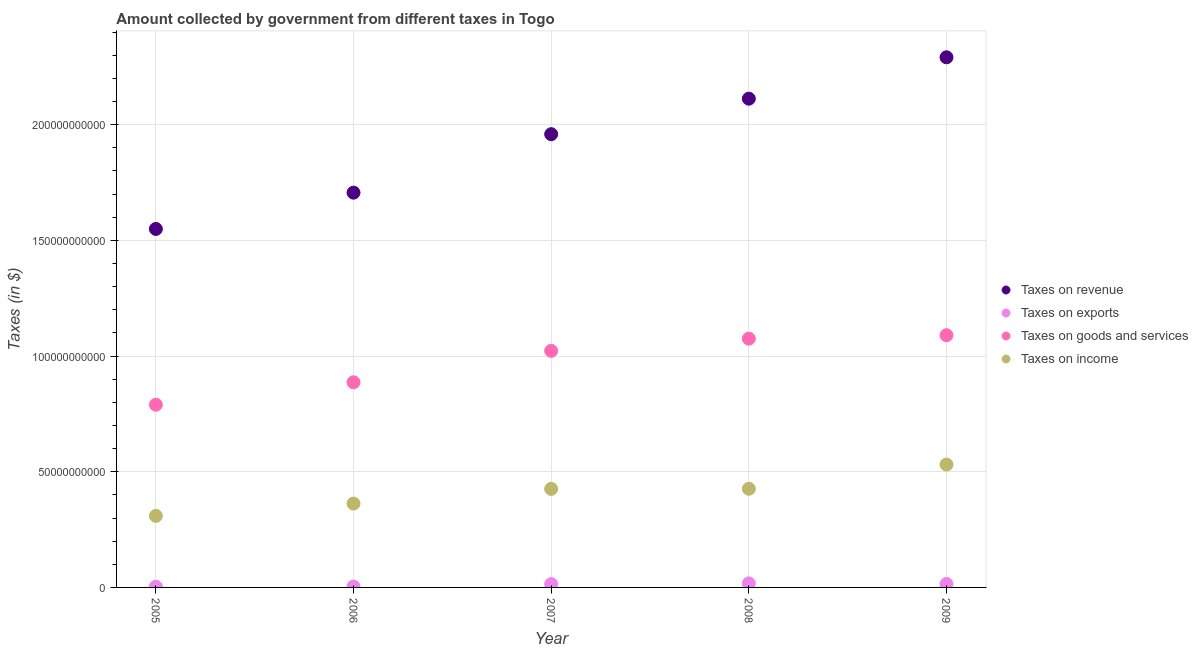Is the number of dotlines equal to the number of legend labels?
Offer a very short reply. Yes. What is the amount collected as tax on revenue in 2006?
Your answer should be compact. 1.71e+11. Across all years, what is the maximum amount collected as tax on goods?
Your response must be concise. 1.09e+11. Across all years, what is the minimum amount collected as tax on revenue?
Keep it short and to the point. 1.55e+11. In which year was the amount collected as tax on exports maximum?
Make the answer very short. 2008. What is the total amount collected as tax on revenue in the graph?
Make the answer very short. 9.62e+11. What is the difference between the amount collected as tax on income in 2006 and that in 2009?
Give a very brief answer. -1.69e+1. What is the difference between the amount collected as tax on income in 2006 and the amount collected as tax on goods in 2008?
Your answer should be very brief. -7.13e+1. What is the average amount collected as tax on revenue per year?
Your response must be concise. 1.92e+11. In the year 2009, what is the difference between the amount collected as tax on goods and amount collected as tax on revenue?
Provide a succinct answer. -1.20e+11. In how many years, is the amount collected as tax on income greater than 220000000000 $?
Make the answer very short. 0. What is the ratio of the amount collected as tax on goods in 2006 to that in 2009?
Make the answer very short. 0.81. Is the amount collected as tax on income in 2005 less than that in 2007?
Your response must be concise. Yes. Is the difference between the amount collected as tax on income in 2005 and 2009 greater than the difference between the amount collected as tax on revenue in 2005 and 2009?
Provide a short and direct response. Yes. What is the difference between the highest and the second highest amount collected as tax on income?
Make the answer very short. 1.05e+1. What is the difference between the highest and the lowest amount collected as tax on exports?
Make the answer very short. 1.45e+09. In how many years, is the amount collected as tax on goods greater than the average amount collected as tax on goods taken over all years?
Your answer should be very brief. 3. Is the sum of the amount collected as tax on revenue in 2007 and 2008 greater than the maximum amount collected as tax on exports across all years?
Ensure brevity in your answer.  Yes. Is it the case that in every year, the sum of the amount collected as tax on revenue and amount collected as tax on exports is greater than the amount collected as tax on goods?
Your answer should be compact. Yes. Is the amount collected as tax on income strictly greater than the amount collected as tax on revenue over the years?
Ensure brevity in your answer.  No. Is the amount collected as tax on revenue strictly less than the amount collected as tax on exports over the years?
Your answer should be compact. No. How many dotlines are there?
Provide a short and direct response. 4. How many years are there in the graph?
Your answer should be compact. 5. What is the difference between two consecutive major ticks on the Y-axis?
Your answer should be compact. 5.00e+1. Are the values on the major ticks of Y-axis written in scientific E-notation?
Make the answer very short. No. Does the graph contain any zero values?
Provide a succinct answer. No. How are the legend labels stacked?
Give a very brief answer. Vertical. What is the title of the graph?
Your answer should be very brief. Amount collected by government from different taxes in Togo. Does "Australia" appear as one of the legend labels in the graph?
Keep it short and to the point. No. What is the label or title of the Y-axis?
Your answer should be compact. Taxes (in $). What is the Taxes (in $) in Taxes on revenue in 2005?
Offer a very short reply. 1.55e+11. What is the Taxes (in $) of Taxes on exports in 2005?
Make the answer very short. 3.14e+08. What is the Taxes (in $) in Taxes on goods and services in 2005?
Ensure brevity in your answer.  7.90e+1. What is the Taxes (in $) in Taxes on income in 2005?
Ensure brevity in your answer.  3.09e+1. What is the Taxes (in $) in Taxes on revenue in 2006?
Provide a succinct answer. 1.71e+11. What is the Taxes (in $) in Taxes on exports in 2006?
Keep it short and to the point. 3.91e+08. What is the Taxes (in $) in Taxes on goods and services in 2006?
Your response must be concise. 8.86e+1. What is the Taxes (in $) in Taxes on income in 2006?
Your answer should be very brief. 3.62e+1. What is the Taxes (in $) of Taxes on revenue in 2007?
Offer a terse response. 1.96e+11. What is the Taxes (in $) in Taxes on exports in 2007?
Provide a succinct answer. 1.43e+09. What is the Taxes (in $) of Taxes on goods and services in 2007?
Offer a terse response. 1.02e+11. What is the Taxes (in $) in Taxes on income in 2007?
Your answer should be very brief. 4.26e+1. What is the Taxes (in $) in Taxes on revenue in 2008?
Make the answer very short. 2.11e+11. What is the Taxes (in $) in Taxes on exports in 2008?
Ensure brevity in your answer.  1.76e+09. What is the Taxes (in $) of Taxes on goods and services in 2008?
Provide a short and direct response. 1.08e+11. What is the Taxes (in $) of Taxes on income in 2008?
Offer a terse response. 4.26e+1. What is the Taxes (in $) of Taxes on revenue in 2009?
Make the answer very short. 2.29e+11. What is the Taxes (in $) of Taxes on exports in 2009?
Offer a very short reply. 1.51e+09. What is the Taxes (in $) in Taxes on goods and services in 2009?
Provide a succinct answer. 1.09e+11. What is the Taxes (in $) of Taxes on income in 2009?
Offer a very short reply. 5.31e+1. Across all years, what is the maximum Taxes (in $) in Taxes on revenue?
Provide a short and direct response. 2.29e+11. Across all years, what is the maximum Taxes (in $) in Taxes on exports?
Provide a short and direct response. 1.76e+09. Across all years, what is the maximum Taxes (in $) in Taxes on goods and services?
Provide a short and direct response. 1.09e+11. Across all years, what is the maximum Taxes (in $) of Taxes on income?
Provide a short and direct response. 5.31e+1. Across all years, what is the minimum Taxes (in $) in Taxes on revenue?
Keep it short and to the point. 1.55e+11. Across all years, what is the minimum Taxes (in $) of Taxes on exports?
Provide a short and direct response. 3.14e+08. Across all years, what is the minimum Taxes (in $) in Taxes on goods and services?
Ensure brevity in your answer.  7.90e+1. Across all years, what is the minimum Taxes (in $) in Taxes on income?
Give a very brief answer. 3.09e+1. What is the total Taxes (in $) in Taxes on revenue in the graph?
Keep it short and to the point. 9.62e+11. What is the total Taxes (in $) in Taxes on exports in the graph?
Offer a terse response. 5.40e+09. What is the total Taxes (in $) in Taxes on goods and services in the graph?
Your answer should be very brief. 4.86e+11. What is the total Taxes (in $) of Taxes on income in the graph?
Your answer should be very brief. 2.05e+11. What is the difference between the Taxes (in $) in Taxes on revenue in 2005 and that in 2006?
Make the answer very short. -1.57e+1. What is the difference between the Taxes (in $) in Taxes on exports in 2005 and that in 2006?
Offer a very short reply. -7.76e+07. What is the difference between the Taxes (in $) of Taxes on goods and services in 2005 and that in 2006?
Your response must be concise. -9.68e+09. What is the difference between the Taxes (in $) in Taxes on income in 2005 and that in 2006?
Your answer should be very brief. -5.30e+09. What is the difference between the Taxes (in $) of Taxes on revenue in 2005 and that in 2007?
Provide a short and direct response. -4.10e+1. What is the difference between the Taxes (in $) of Taxes on exports in 2005 and that in 2007?
Your answer should be very brief. -1.12e+09. What is the difference between the Taxes (in $) in Taxes on goods and services in 2005 and that in 2007?
Provide a succinct answer. -2.33e+1. What is the difference between the Taxes (in $) of Taxes on income in 2005 and that in 2007?
Keep it short and to the point. -1.17e+1. What is the difference between the Taxes (in $) in Taxes on revenue in 2005 and that in 2008?
Your answer should be compact. -5.63e+1. What is the difference between the Taxes (in $) in Taxes on exports in 2005 and that in 2008?
Give a very brief answer. -1.45e+09. What is the difference between the Taxes (in $) of Taxes on goods and services in 2005 and that in 2008?
Keep it short and to the point. -2.85e+1. What is the difference between the Taxes (in $) in Taxes on income in 2005 and that in 2008?
Provide a short and direct response. -1.17e+1. What is the difference between the Taxes (in $) of Taxes on revenue in 2005 and that in 2009?
Offer a very short reply. -7.42e+1. What is the difference between the Taxes (in $) in Taxes on exports in 2005 and that in 2009?
Offer a very short reply. -1.19e+09. What is the difference between the Taxes (in $) in Taxes on goods and services in 2005 and that in 2009?
Give a very brief answer. -3.00e+1. What is the difference between the Taxes (in $) of Taxes on income in 2005 and that in 2009?
Offer a terse response. -2.22e+1. What is the difference between the Taxes (in $) in Taxes on revenue in 2006 and that in 2007?
Your answer should be compact. -2.53e+1. What is the difference between the Taxes (in $) of Taxes on exports in 2006 and that in 2007?
Offer a terse response. -1.04e+09. What is the difference between the Taxes (in $) of Taxes on goods and services in 2006 and that in 2007?
Your answer should be very brief. -1.36e+1. What is the difference between the Taxes (in $) of Taxes on income in 2006 and that in 2007?
Give a very brief answer. -6.35e+09. What is the difference between the Taxes (in $) of Taxes on revenue in 2006 and that in 2008?
Give a very brief answer. -4.06e+1. What is the difference between the Taxes (in $) of Taxes on exports in 2006 and that in 2008?
Your answer should be compact. -1.37e+09. What is the difference between the Taxes (in $) in Taxes on goods and services in 2006 and that in 2008?
Provide a short and direct response. -1.89e+1. What is the difference between the Taxes (in $) of Taxes on income in 2006 and that in 2008?
Give a very brief answer. -6.41e+09. What is the difference between the Taxes (in $) in Taxes on revenue in 2006 and that in 2009?
Your answer should be compact. -5.85e+1. What is the difference between the Taxes (in $) in Taxes on exports in 2006 and that in 2009?
Give a very brief answer. -1.11e+09. What is the difference between the Taxes (in $) of Taxes on goods and services in 2006 and that in 2009?
Offer a very short reply. -2.04e+1. What is the difference between the Taxes (in $) of Taxes on income in 2006 and that in 2009?
Your answer should be very brief. -1.69e+1. What is the difference between the Taxes (in $) of Taxes on revenue in 2007 and that in 2008?
Give a very brief answer. -1.53e+1. What is the difference between the Taxes (in $) in Taxes on exports in 2007 and that in 2008?
Offer a terse response. -3.30e+08. What is the difference between the Taxes (in $) in Taxes on goods and services in 2007 and that in 2008?
Give a very brief answer. -5.28e+09. What is the difference between the Taxes (in $) in Taxes on income in 2007 and that in 2008?
Your response must be concise. -5.46e+07. What is the difference between the Taxes (in $) in Taxes on revenue in 2007 and that in 2009?
Your answer should be compact. -3.32e+1. What is the difference between the Taxes (in $) in Taxes on exports in 2007 and that in 2009?
Your answer should be very brief. -7.58e+07. What is the difference between the Taxes (in $) of Taxes on goods and services in 2007 and that in 2009?
Your answer should be very brief. -6.76e+09. What is the difference between the Taxes (in $) of Taxes on income in 2007 and that in 2009?
Ensure brevity in your answer.  -1.05e+1. What is the difference between the Taxes (in $) in Taxes on revenue in 2008 and that in 2009?
Make the answer very short. -1.79e+1. What is the difference between the Taxes (in $) in Taxes on exports in 2008 and that in 2009?
Keep it short and to the point. 2.54e+08. What is the difference between the Taxes (in $) in Taxes on goods and services in 2008 and that in 2009?
Give a very brief answer. -1.49e+09. What is the difference between the Taxes (in $) of Taxes on income in 2008 and that in 2009?
Keep it short and to the point. -1.05e+1. What is the difference between the Taxes (in $) of Taxes on revenue in 2005 and the Taxes (in $) of Taxes on exports in 2006?
Give a very brief answer. 1.55e+11. What is the difference between the Taxes (in $) of Taxes on revenue in 2005 and the Taxes (in $) of Taxes on goods and services in 2006?
Provide a short and direct response. 6.63e+1. What is the difference between the Taxes (in $) of Taxes on revenue in 2005 and the Taxes (in $) of Taxes on income in 2006?
Your answer should be very brief. 1.19e+11. What is the difference between the Taxes (in $) of Taxes on exports in 2005 and the Taxes (in $) of Taxes on goods and services in 2006?
Keep it short and to the point. -8.83e+1. What is the difference between the Taxes (in $) of Taxes on exports in 2005 and the Taxes (in $) of Taxes on income in 2006?
Ensure brevity in your answer.  -3.59e+1. What is the difference between the Taxes (in $) of Taxes on goods and services in 2005 and the Taxes (in $) of Taxes on income in 2006?
Your response must be concise. 4.27e+1. What is the difference between the Taxes (in $) in Taxes on revenue in 2005 and the Taxes (in $) in Taxes on exports in 2007?
Provide a short and direct response. 1.53e+11. What is the difference between the Taxes (in $) of Taxes on revenue in 2005 and the Taxes (in $) of Taxes on goods and services in 2007?
Provide a short and direct response. 5.27e+1. What is the difference between the Taxes (in $) in Taxes on revenue in 2005 and the Taxes (in $) in Taxes on income in 2007?
Make the answer very short. 1.12e+11. What is the difference between the Taxes (in $) in Taxes on exports in 2005 and the Taxes (in $) in Taxes on goods and services in 2007?
Provide a succinct answer. -1.02e+11. What is the difference between the Taxes (in $) in Taxes on exports in 2005 and the Taxes (in $) in Taxes on income in 2007?
Give a very brief answer. -4.23e+1. What is the difference between the Taxes (in $) of Taxes on goods and services in 2005 and the Taxes (in $) of Taxes on income in 2007?
Ensure brevity in your answer.  3.64e+1. What is the difference between the Taxes (in $) in Taxes on revenue in 2005 and the Taxes (in $) in Taxes on exports in 2008?
Ensure brevity in your answer.  1.53e+11. What is the difference between the Taxes (in $) in Taxes on revenue in 2005 and the Taxes (in $) in Taxes on goods and services in 2008?
Your response must be concise. 4.74e+1. What is the difference between the Taxes (in $) of Taxes on revenue in 2005 and the Taxes (in $) of Taxes on income in 2008?
Your answer should be compact. 1.12e+11. What is the difference between the Taxes (in $) of Taxes on exports in 2005 and the Taxes (in $) of Taxes on goods and services in 2008?
Your response must be concise. -1.07e+11. What is the difference between the Taxes (in $) in Taxes on exports in 2005 and the Taxes (in $) in Taxes on income in 2008?
Give a very brief answer. -4.23e+1. What is the difference between the Taxes (in $) in Taxes on goods and services in 2005 and the Taxes (in $) in Taxes on income in 2008?
Give a very brief answer. 3.63e+1. What is the difference between the Taxes (in $) of Taxes on revenue in 2005 and the Taxes (in $) of Taxes on exports in 2009?
Keep it short and to the point. 1.53e+11. What is the difference between the Taxes (in $) in Taxes on revenue in 2005 and the Taxes (in $) in Taxes on goods and services in 2009?
Keep it short and to the point. 4.59e+1. What is the difference between the Taxes (in $) in Taxes on revenue in 2005 and the Taxes (in $) in Taxes on income in 2009?
Give a very brief answer. 1.02e+11. What is the difference between the Taxes (in $) of Taxes on exports in 2005 and the Taxes (in $) of Taxes on goods and services in 2009?
Offer a very short reply. -1.09e+11. What is the difference between the Taxes (in $) in Taxes on exports in 2005 and the Taxes (in $) in Taxes on income in 2009?
Keep it short and to the point. -5.28e+1. What is the difference between the Taxes (in $) in Taxes on goods and services in 2005 and the Taxes (in $) in Taxes on income in 2009?
Your response must be concise. 2.59e+1. What is the difference between the Taxes (in $) of Taxes on revenue in 2006 and the Taxes (in $) of Taxes on exports in 2007?
Ensure brevity in your answer.  1.69e+11. What is the difference between the Taxes (in $) of Taxes on revenue in 2006 and the Taxes (in $) of Taxes on goods and services in 2007?
Your response must be concise. 6.84e+1. What is the difference between the Taxes (in $) of Taxes on revenue in 2006 and the Taxes (in $) of Taxes on income in 2007?
Ensure brevity in your answer.  1.28e+11. What is the difference between the Taxes (in $) in Taxes on exports in 2006 and the Taxes (in $) in Taxes on goods and services in 2007?
Give a very brief answer. -1.02e+11. What is the difference between the Taxes (in $) in Taxes on exports in 2006 and the Taxes (in $) in Taxes on income in 2007?
Your response must be concise. -4.22e+1. What is the difference between the Taxes (in $) in Taxes on goods and services in 2006 and the Taxes (in $) in Taxes on income in 2007?
Provide a short and direct response. 4.61e+1. What is the difference between the Taxes (in $) in Taxes on revenue in 2006 and the Taxes (in $) in Taxes on exports in 2008?
Provide a succinct answer. 1.69e+11. What is the difference between the Taxes (in $) in Taxes on revenue in 2006 and the Taxes (in $) in Taxes on goods and services in 2008?
Your answer should be compact. 6.31e+1. What is the difference between the Taxes (in $) of Taxes on revenue in 2006 and the Taxes (in $) of Taxes on income in 2008?
Offer a terse response. 1.28e+11. What is the difference between the Taxes (in $) of Taxes on exports in 2006 and the Taxes (in $) of Taxes on goods and services in 2008?
Give a very brief answer. -1.07e+11. What is the difference between the Taxes (in $) of Taxes on exports in 2006 and the Taxes (in $) of Taxes on income in 2008?
Keep it short and to the point. -4.22e+1. What is the difference between the Taxes (in $) of Taxes on goods and services in 2006 and the Taxes (in $) of Taxes on income in 2008?
Your answer should be very brief. 4.60e+1. What is the difference between the Taxes (in $) of Taxes on revenue in 2006 and the Taxes (in $) of Taxes on exports in 2009?
Provide a short and direct response. 1.69e+11. What is the difference between the Taxes (in $) of Taxes on revenue in 2006 and the Taxes (in $) of Taxes on goods and services in 2009?
Offer a very short reply. 6.16e+1. What is the difference between the Taxes (in $) in Taxes on revenue in 2006 and the Taxes (in $) in Taxes on income in 2009?
Make the answer very short. 1.17e+11. What is the difference between the Taxes (in $) of Taxes on exports in 2006 and the Taxes (in $) of Taxes on goods and services in 2009?
Offer a very short reply. -1.09e+11. What is the difference between the Taxes (in $) in Taxes on exports in 2006 and the Taxes (in $) in Taxes on income in 2009?
Offer a terse response. -5.27e+1. What is the difference between the Taxes (in $) in Taxes on goods and services in 2006 and the Taxes (in $) in Taxes on income in 2009?
Make the answer very short. 3.55e+1. What is the difference between the Taxes (in $) in Taxes on revenue in 2007 and the Taxes (in $) in Taxes on exports in 2008?
Your response must be concise. 1.94e+11. What is the difference between the Taxes (in $) of Taxes on revenue in 2007 and the Taxes (in $) of Taxes on goods and services in 2008?
Your answer should be very brief. 8.84e+1. What is the difference between the Taxes (in $) of Taxes on revenue in 2007 and the Taxes (in $) of Taxes on income in 2008?
Give a very brief answer. 1.53e+11. What is the difference between the Taxes (in $) in Taxes on exports in 2007 and the Taxes (in $) in Taxes on goods and services in 2008?
Keep it short and to the point. -1.06e+11. What is the difference between the Taxes (in $) of Taxes on exports in 2007 and the Taxes (in $) of Taxes on income in 2008?
Provide a short and direct response. -4.12e+1. What is the difference between the Taxes (in $) in Taxes on goods and services in 2007 and the Taxes (in $) in Taxes on income in 2008?
Make the answer very short. 5.96e+1. What is the difference between the Taxes (in $) of Taxes on revenue in 2007 and the Taxes (in $) of Taxes on exports in 2009?
Ensure brevity in your answer.  1.94e+11. What is the difference between the Taxes (in $) in Taxes on revenue in 2007 and the Taxes (in $) in Taxes on goods and services in 2009?
Offer a very short reply. 8.69e+1. What is the difference between the Taxes (in $) in Taxes on revenue in 2007 and the Taxes (in $) in Taxes on income in 2009?
Provide a succinct answer. 1.43e+11. What is the difference between the Taxes (in $) in Taxes on exports in 2007 and the Taxes (in $) in Taxes on goods and services in 2009?
Your answer should be compact. -1.08e+11. What is the difference between the Taxes (in $) of Taxes on exports in 2007 and the Taxes (in $) of Taxes on income in 2009?
Provide a succinct answer. -5.17e+1. What is the difference between the Taxes (in $) in Taxes on goods and services in 2007 and the Taxes (in $) in Taxes on income in 2009?
Your answer should be compact. 4.91e+1. What is the difference between the Taxes (in $) in Taxes on revenue in 2008 and the Taxes (in $) in Taxes on exports in 2009?
Provide a short and direct response. 2.10e+11. What is the difference between the Taxes (in $) of Taxes on revenue in 2008 and the Taxes (in $) of Taxes on goods and services in 2009?
Ensure brevity in your answer.  1.02e+11. What is the difference between the Taxes (in $) in Taxes on revenue in 2008 and the Taxes (in $) in Taxes on income in 2009?
Offer a very short reply. 1.58e+11. What is the difference between the Taxes (in $) in Taxes on exports in 2008 and the Taxes (in $) in Taxes on goods and services in 2009?
Keep it short and to the point. -1.07e+11. What is the difference between the Taxes (in $) in Taxes on exports in 2008 and the Taxes (in $) in Taxes on income in 2009?
Offer a terse response. -5.13e+1. What is the difference between the Taxes (in $) in Taxes on goods and services in 2008 and the Taxes (in $) in Taxes on income in 2009?
Keep it short and to the point. 5.44e+1. What is the average Taxes (in $) in Taxes on revenue per year?
Your response must be concise. 1.92e+11. What is the average Taxes (in $) of Taxes on exports per year?
Your answer should be compact. 1.08e+09. What is the average Taxes (in $) of Taxes on goods and services per year?
Provide a succinct answer. 9.73e+1. What is the average Taxes (in $) of Taxes on income per year?
Keep it short and to the point. 4.11e+1. In the year 2005, what is the difference between the Taxes (in $) in Taxes on revenue and Taxes (in $) in Taxes on exports?
Your answer should be compact. 1.55e+11. In the year 2005, what is the difference between the Taxes (in $) in Taxes on revenue and Taxes (in $) in Taxes on goods and services?
Your answer should be compact. 7.59e+1. In the year 2005, what is the difference between the Taxes (in $) in Taxes on revenue and Taxes (in $) in Taxes on income?
Make the answer very short. 1.24e+11. In the year 2005, what is the difference between the Taxes (in $) in Taxes on exports and Taxes (in $) in Taxes on goods and services?
Give a very brief answer. -7.86e+1. In the year 2005, what is the difference between the Taxes (in $) of Taxes on exports and Taxes (in $) of Taxes on income?
Make the answer very short. -3.06e+1. In the year 2005, what is the difference between the Taxes (in $) in Taxes on goods and services and Taxes (in $) in Taxes on income?
Make the answer very short. 4.80e+1. In the year 2006, what is the difference between the Taxes (in $) of Taxes on revenue and Taxes (in $) of Taxes on exports?
Keep it short and to the point. 1.70e+11. In the year 2006, what is the difference between the Taxes (in $) of Taxes on revenue and Taxes (in $) of Taxes on goods and services?
Provide a succinct answer. 8.19e+1. In the year 2006, what is the difference between the Taxes (in $) in Taxes on revenue and Taxes (in $) in Taxes on income?
Provide a short and direct response. 1.34e+11. In the year 2006, what is the difference between the Taxes (in $) in Taxes on exports and Taxes (in $) in Taxes on goods and services?
Your answer should be compact. -8.83e+1. In the year 2006, what is the difference between the Taxes (in $) of Taxes on exports and Taxes (in $) of Taxes on income?
Provide a short and direct response. -3.58e+1. In the year 2006, what is the difference between the Taxes (in $) of Taxes on goods and services and Taxes (in $) of Taxes on income?
Your answer should be very brief. 5.24e+1. In the year 2007, what is the difference between the Taxes (in $) of Taxes on revenue and Taxes (in $) of Taxes on exports?
Keep it short and to the point. 1.94e+11. In the year 2007, what is the difference between the Taxes (in $) in Taxes on revenue and Taxes (in $) in Taxes on goods and services?
Give a very brief answer. 9.36e+1. In the year 2007, what is the difference between the Taxes (in $) in Taxes on revenue and Taxes (in $) in Taxes on income?
Ensure brevity in your answer.  1.53e+11. In the year 2007, what is the difference between the Taxes (in $) of Taxes on exports and Taxes (in $) of Taxes on goods and services?
Give a very brief answer. -1.01e+11. In the year 2007, what is the difference between the Taxes (in $) in Taxes on exports and Taxes (in $) in Taxes on income?
Keep it short and to the point. -4.12e+1. In the year 2007, what is the difference between the Taxes (in $) in Taxes on goods and services and Taxes (in $) in Taxes on income?
Ensure brevity in your answer.  5.97e+1. In the year 2008, what is the difference between the Taxes (in $) in Taxes on revenue and Taxes (in $) in Taxes on exports?
Keep it short and to the point. 2.09e+11. In the year 2008, what is the difference between the Taxes (in $) of Taxes on revenue and Taxes (in $) of Taxes on goods and services?
Give a very brief answer. 1.04e+11. In the year 2008, what is the difference between the Taxes (in $) of Taxes on revenue and Taxes (in $) of Taxes on income?
Offer a terse response. 1.69e+11. In the year 2008, what is the difference between the Taxes (in $) in Taxes on exports and Taxes (in $) in Taxes on goods and services?
Offer a terse response. -1.06e+11. In the year 2008, what is the difference between the Taxes (in $) in Taxes on exports and Taxes (in $) in Taxes on income?
Your answer should be very brief. -4.09e+1. In the year 2008, what is the difference between the Taxes (in $) in Taxes on goods and services and Taxes (in $) in Taxes on income?
Your response must be concise. 6.49e+1. In the year 2009, what is the difference between the Taxes (in $) of Taxes on revenue and Taxes (in $) of Taxes on exports?
Make the answer very short. 2.28e+11. In the year 2009, what is the difference between the Taxes (in $) of Taxes on revenue and Taxes (in $) of Taxes on goods and services?
Ensure brevity in your answer.  1.20e+11. In the year 2009, what is the difference between the Taxes (in $) of Taxes on revenue and Taxes (in $) of Taxes on income?
Offer a very short reply. 1.76e+11. In the year 2009, what is the difference between the Taxes (in $) of Taxes on exports and Taxes (in $) of Taxes on goods and services?
Offer a terse response. -1.07e+11. In the year 2009, what is the difference between the Taxes (in $) of Taxes on exports and Taxes (in $) of Taxes on income?
Offer a terse response. -5.16e+1. In the year 2009, what is the difference between the Taxes (in $) of Taxes on goods and services and Taxes (in $) of Taxes on income?
Keep it short and to the point. 5.59e+1. What is the ratio of the Taxes (in $) of Taxes on revenue in 2005 to that in 2006?
Ensure brevity in your answer.  0.91. What is the ratio of the Taxes (in $) of Taxes on exports in 2005 to that in 2006?
Your answer should be very brief. 0.8. What is the ratio of the Taxes (in $) in Taxes on goods and services in 2005 to that in 2006?
Make the answer very short. 0.89. What is the ratio of the Taxes (in $) in Taxes on income in 2005 to that in 2006?
Offer a terse response. 0.85. What is the ratio of the Taxes (in $) of Taxes on revenue in 2005 to that in 2007?
Make the answer very short. 0.79. What is the ratio of the Taxes (in $) in Taxes on exports in 2005 to that in 2007?
Give a very brief answer. 0.22. What is the ratio of the Taxes (in $) in Taxes on goods and services in 2005 to that in 2007?
Offer a terse response. 0.77. What is the ratio of the Taxes (in $) of Taxes on income in 2005 to that in 2007?
Your response must be concise. 0.73. What is the ratio of the Taxes (in $) of Taxes on revenue in 2005 to that in 2008?
Offer a very short reply. 0.73. What is the ratio of the Taxes (in $) of Taxes on exports in 2005 to that in 2008?
Give a very brief answer. 0.18. What is the ratio of the Taxes (in $) of Taxes on goods and services in 2005 to that in 2008?
Provide a short and direct response. 0.73. What is the ratio of the Taxes (in $) in Taxes on income in 2005 to that in 2008?
Your response must be concise. 0.73. What is the ratio of the Taxes (in $) in Taxes on revenue in 2005 to that in 2009?
Your response must be concise. 0.68. What is the ratio of the Taxes (in $) of Taxes on exports in 2005 to that in 2009?
Ensure brevity in your answer.  0.21. What is the ratio of the Taxes (in $) of Taxes on goods and services in 2005 to that in 2009?
Keep it short and to the point. 0.72. What is the ratio of the Taxes (in $) of Taxes on income in 2005 to that in 2009?
Provide a succinct answer. 0.58. What is the ratio of the Taxes (in $) in Taxes on revenue in 2006 to that in 2007?
Provide a short and direct response. 0.87. What is the ratio of the Taxes (in $) of Taxes on exports in 2006 to that in 2007?
Give a very brief answer. 0.27. What is the ratio of the Taxes (in $) of Taxes on goods and services in 2006 to that in 2007?
Make the answer very short. 0.87. What is the ratio of the Taxes (in $) of Taxes on income in 2006 to that in 2007?
Your response must be concise. 0.85. What is the ratio of the Taxes (in $) in Taxes on revenue in 2006 to that in 2008?
Ensure brevity in your answer.  0.81. What is the ratio of the Taxes (in $) of Taxes on exports in 2006 to that in 2008?
Offer a terse response. 0.22. What is the ratio of the Taxes (in $) of Taxes on goods and services in 2006 to that in 2008?
Keep it short and to the point. 0.82. What is the ratio of the Taxes (in $) of Taxes on income in 2006 to that in 2008?
Your response must be concise. 0.85. What is the ratio of the Taxes (in $) of Taxes on revenue in 2006 to that in 2009?
Provide a succinct answer. 0.74. What is the ratio of the Taxes (in $) of Taxes on exports in 2006 to that in 2009?
Provide a succinct answer. 0.26. What is the ratio of the Taxes (in $) in Taxes on goods and services in 2006 to that in 2009?
Give a very brief answer. 0.81. What is the ratio of the Taxes (in $) in Taxes on income in 2006 to that in 2009?
Your answer should be very brief. 0.68. What is the ratio of the Taxes (in $) in Taxes on revenue in 2007 to that in 2008?
Provide a short and direct response. 0.93. What is the ratio of the Taxes (in $) in Taxes on exports in 2007 to that in 2008?
Your answer should be very brief. 0.81. What is the ratio of the Taxes (in $) of Taxes on goods and services in 2007 to that in 2008?
Make the answer very short. 0.95. What is the ratio of the Taxes (in $) of Taxes on revenue in 2007 to that in 2009?
Ensure brevity in your answer.  0.85. What is the ratio of the Taxes (in $) of Taxes on exports in 2007 to that in 2009?
Offer a very short reply. 0.95. What is the ratio of the Taxes (in $) in Taxes on goods and services in 2007 to that in 2009?
Provide a succinct answer. 0.94. What is the ratio of the Taxes (in $) of Taxes on income in 2007 to that in 2009?
Offer a terse response. 0.8. What is the ratio of the Taxes (in $) in Taxes on revenue in 2008 to that in 2009?
Make the answer very short. 0.92. What is the ratio of the Taxes (in $) in Taxes on exports in 2008 to that in 2009?
Your answer should be compact. 1.17. What is the ratio of the Taxes (in $) in Taxes on goods and services in 2008 to that in 2009?
Your answer should be very brief. 0.99. What is the ratio of the Taxes (in $) of Taxes on income in 2008 to that in 2009?
Offer a very short reply. 0.8. What is the difference between the highest and the second highest Taxes (in $) in Taxes on revenue?
Make the answer very short. 1.79e+1. What is the difference between the highest and the second highest Taxes (in $) of Taxes on exports?
Your answer should be very brief. 2.54e+08. What is the difference between the highest and the second highest Taxes (in $) in Taxes on goods and services?
Offer a terse response. 1.49e+09. What is the difference between the highest and the second highest Taxes (in $) of Taxes on income?
Provide a short and direct response. 1.05e+1. What is the difference between the highest and the lowest Taxes (in $) in Taxes on revenue?
Your response must be concise. 7.42e+1. What is the difference between the highest and the lowest Taxes (in $) of Taxes on exports?
Provide a short and direct response. 1.45e+09. What is the difference between the highest and the lowest Taxes (in $) of Taxes on goods and services?
Make the answer very short. 3.00e+1. What is the difference between the highest and the lowest Taxes (in $) in Taxes on income?
Your answer should be very brief. 2.22e+1. 